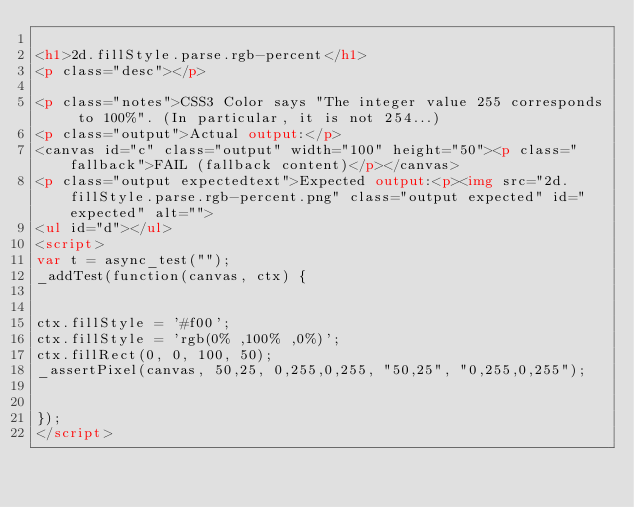Convert code to text. <code><loc_0><loc_0><loc_500><loc_500><_HTML_>
<h1>2d.fillStyle.parse.rgb-percent</h1>
<p class="desc"></p>

<p class="notes">CSS3 Color says "The integer value 255 corresponds to 100%". (In particular, it is not 254...)
<p class="output">Actual output:</p>
<canvas id="c" class="output" width="100" height="50"><p class="fallback">FAIL (fallback content)</p></canvas>
<p class="output expectedtext">Expected output:<p><img src="2d.fillStyle.parse.rgb-percent.png" class="output expected" id="expected" alt="">
<ul id="d"></ul>
<script>
var t = async_test("");
_addTest(function(canvas, ctx) {


ctx.fillStyle = '#f00';
ctx.fillStyle = 'rgb(0% ,100% ,0%)';
ctx.fillRect(0, 0, 100, 50);
_assertPixel(canvas, 50,25, 0,255,0,255, "50,25", "0,255,0,255");


});
</script>

</code> 